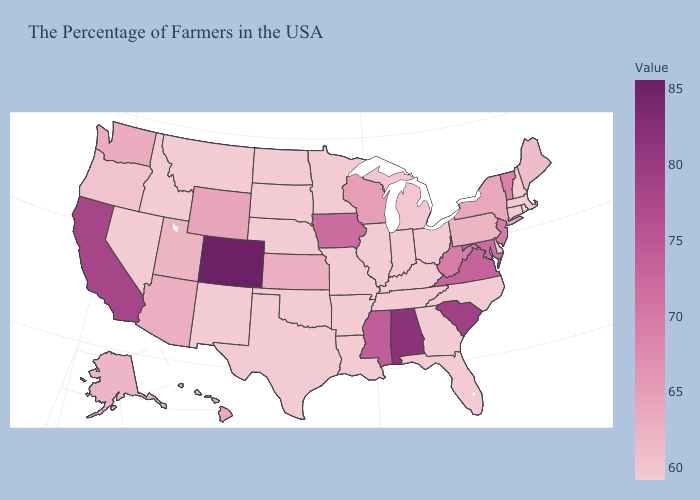Does South Carolina have the lowest value in the USA?
Be succinct. No. Which states hav the highest value in the Northeast?
Give a very brief answer. New Jersey. Is the legend a continuous bar?
Answer briefly. Yes. Which states hav the highest value in the South?
Answer briefly. Alabama. Does Alaska have the highest value in the West?
Give a very brief answer. No. Which states hav the highest value in the West?
Give a very brief answer. Colorado. 